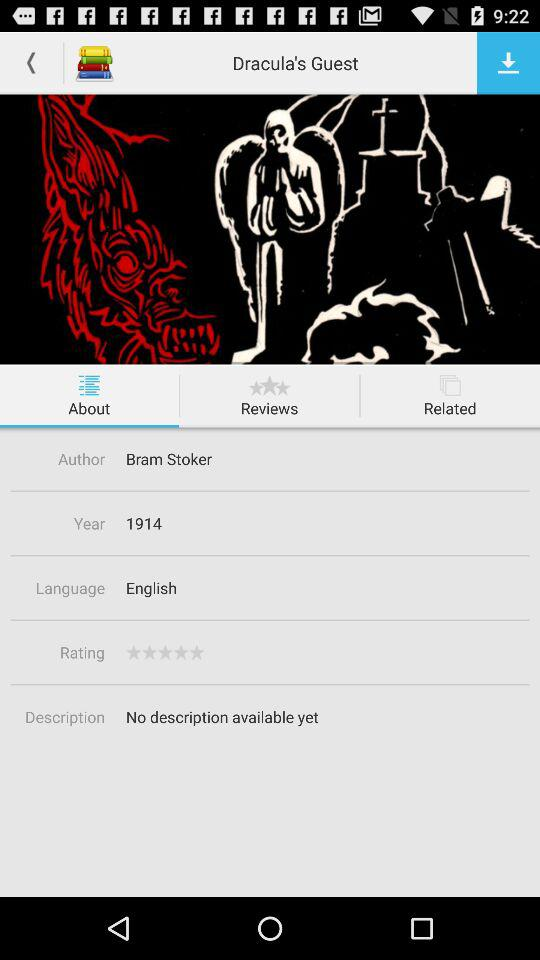What is the year? The year is 1914. 